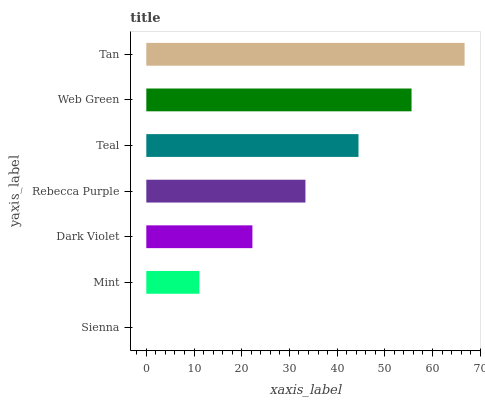Is Sienna the minimum?
Answer yes or no. Yes. Is Tan the maximum?
Answer yes or no. Yes. Is Mint the minimum?
Answer yes or no. No. Is Mint the maximum?
Answer yes or no. No. Is Mint greater than Sienna?
Answer yes or no. Yes. Is Sienna less than Mint?
Answer yes or no. Yes. Is Sienna greater than Mint?
Answer yes or no. No. Is Mint less than Sienna?
Answer yes or no. No. Is Rebecca Purple the high median?
Answer yes or no. Yes. Is Rebecca Purple the low median?
Answer yes or no. Yes. Is Web Green the high median?
Answer yes or no. No. Is Dark Violet the low median?
Answer yes or no. No. 